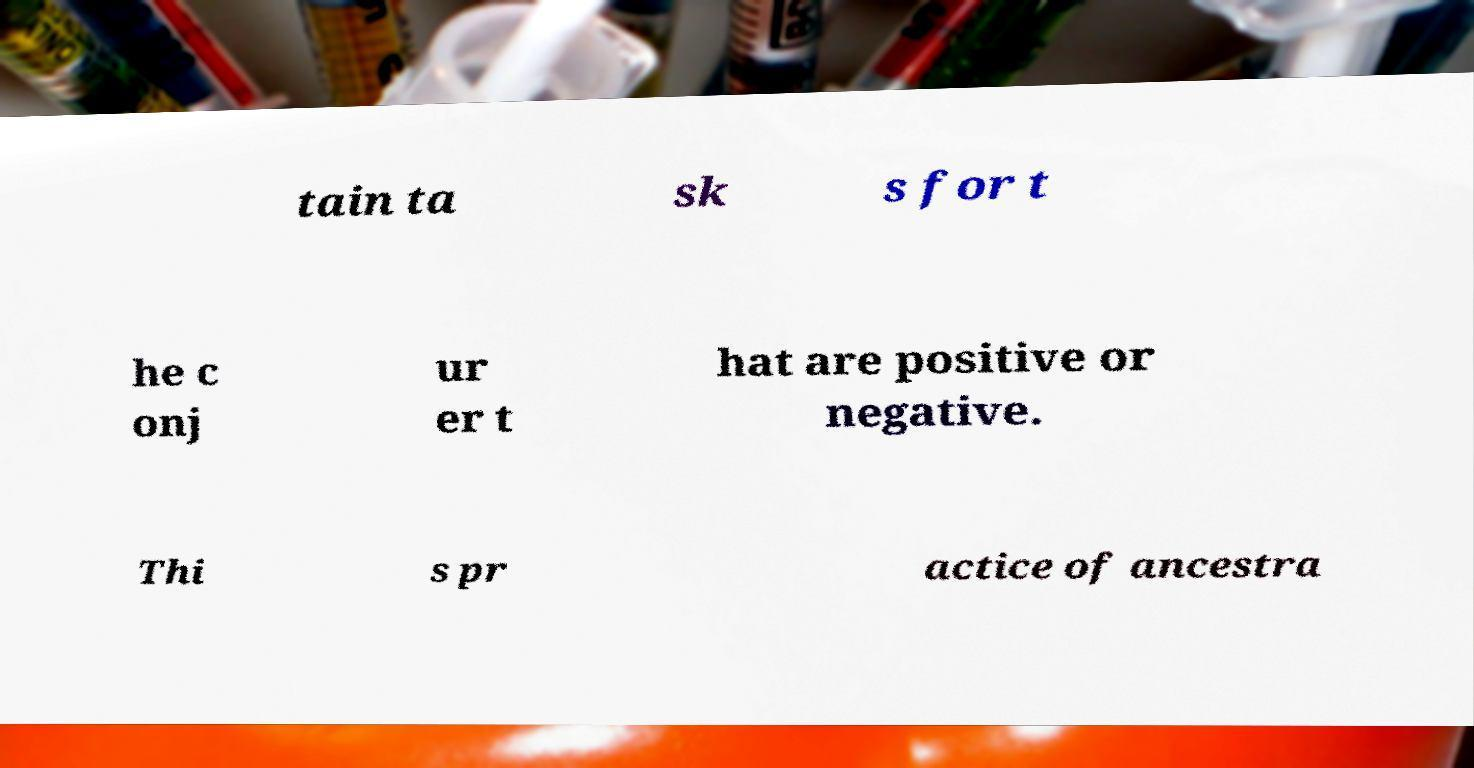Could you extract and type out the text from this image? tain ta sk s for t he c onj ur er t hat are positive or negative. Thi s pr actice of ancestra 